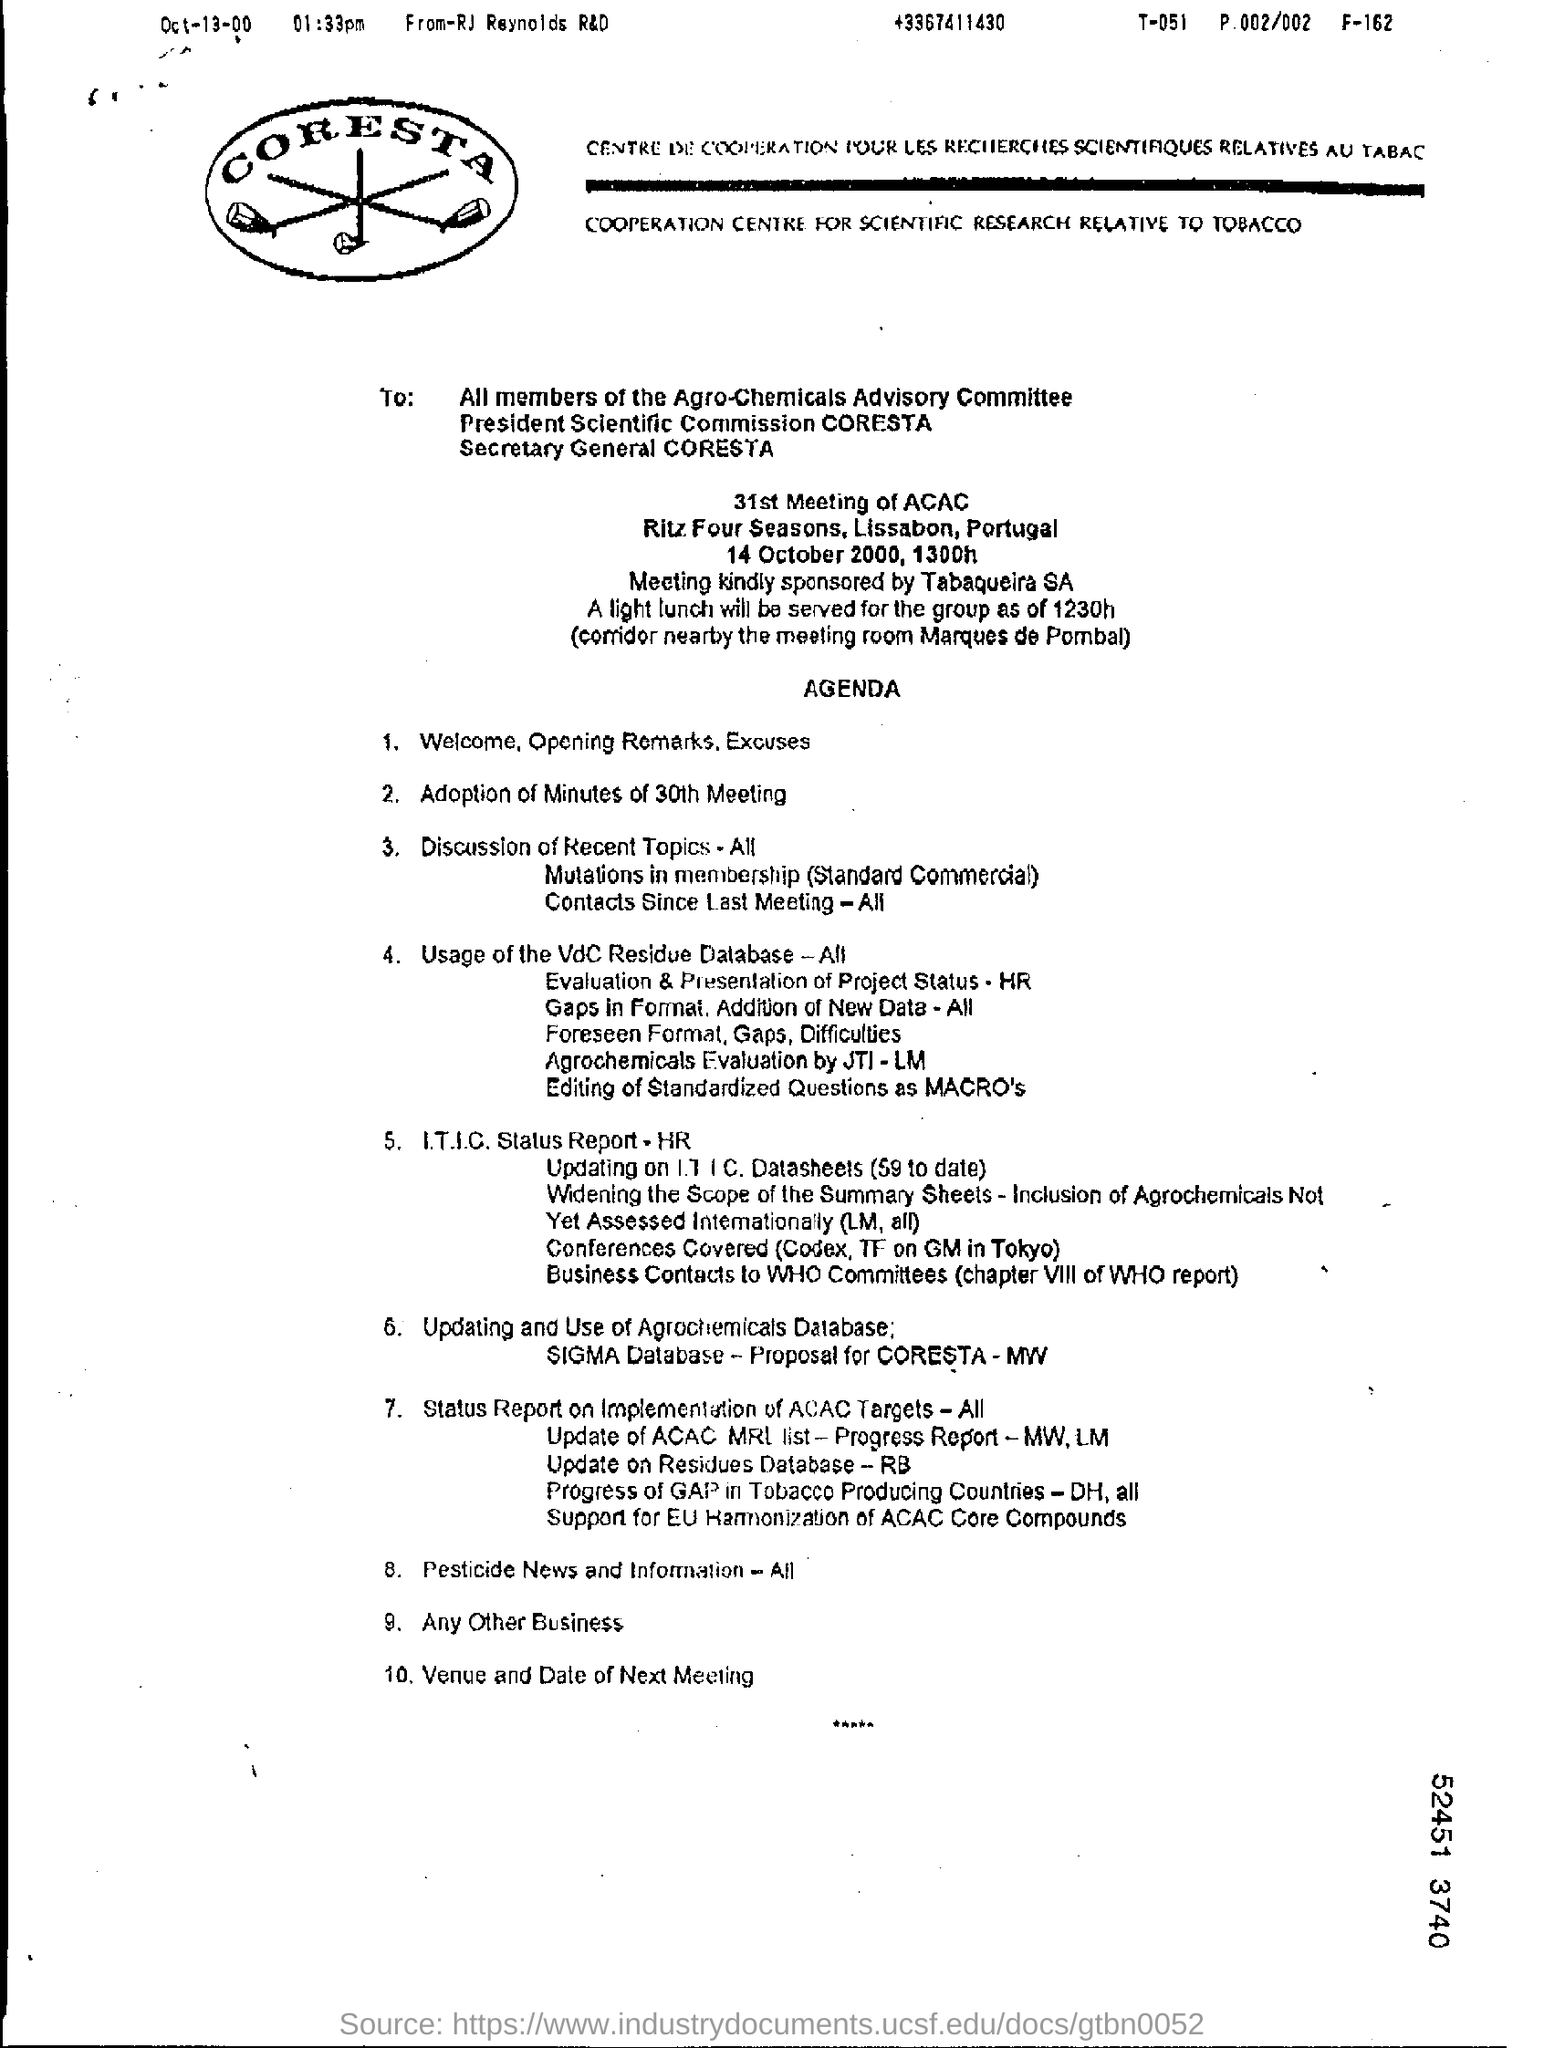What is written in capital letters inside logo?
Offer a very short reply. CORESTA. What is the date written at the left top corner of the page?
Offer a very short reply. Oct-13-00. Who has written this document?
Keep it short and to the point. RJ Reynolds R&D. Which date is the meeting?
Keep it short and to the point. 14 October 2000. Meeting is at what time?
Give a very brief answer. 1300h. Who is sponsoring the meeting?
Your answer should be compact. Tabaqueira sa. Lunch will be served for the group at what time?
Keep it short and to the point. 1230h. Agenda points is for "31st Meeting of" which committee?
Give a very brief answer. Agro-chemicals advisory committee. 